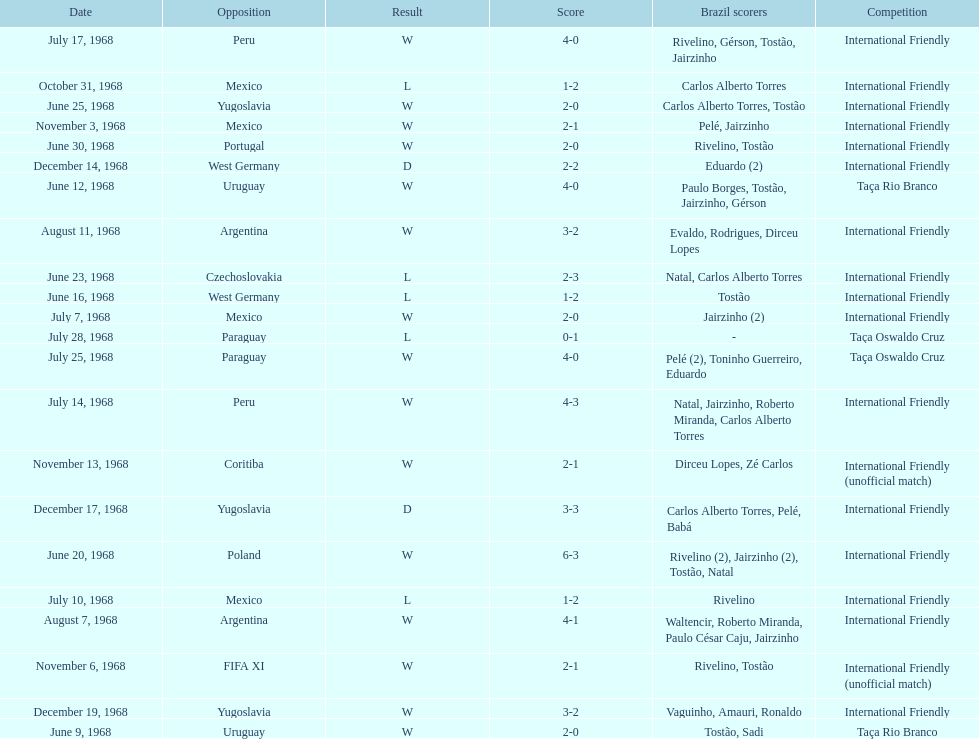The most goals scored by brazil in a game 6. 